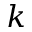<formula> <loc_0><loc_0><loc_500><loc_500>k</formula> 